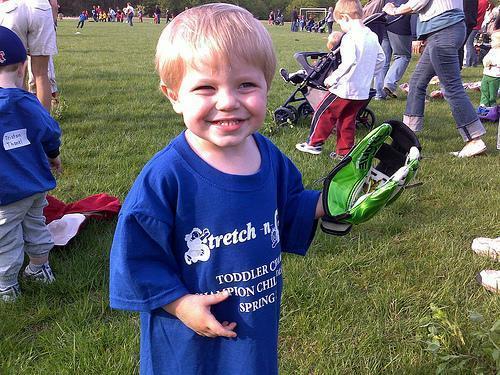How many gloves does the boy have?
Give a very brief answer. 1. How many strollers are there?
Give a very brief answer. 1. 